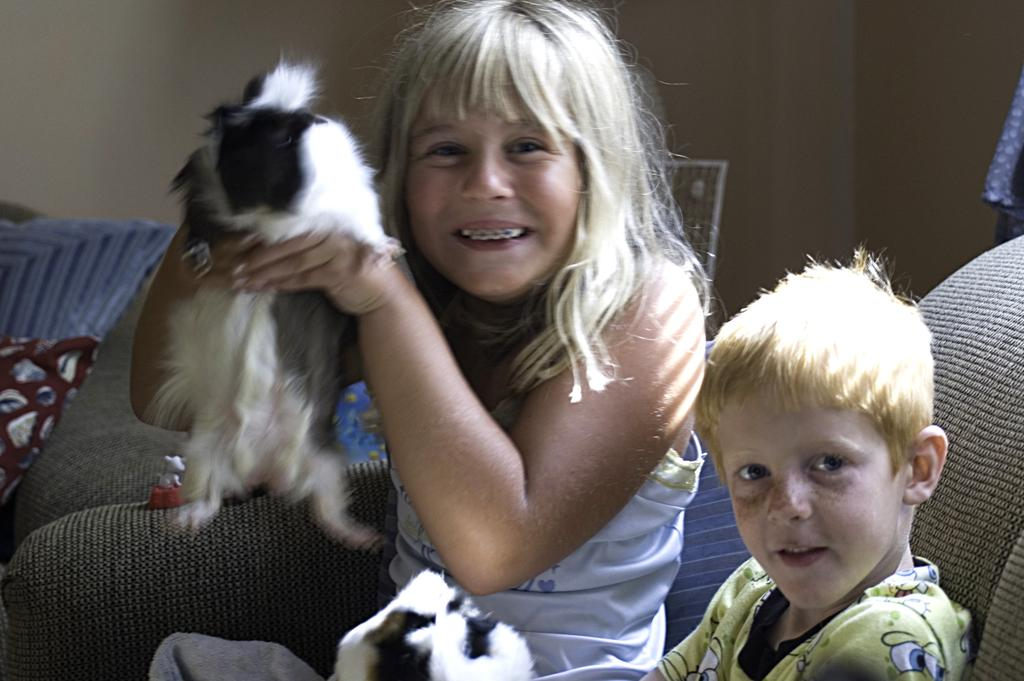Who is present in the image? There is a girl and a boy in the image. What is the girl holding in the image? The girl is holding a dog. What is the girl's facial expression in the image? The girl is smiling. What is the boy doing in the image? The boy is sitting on a chair. What type of engine can be seen in the image? There is no engine present in the image. What word is the girl saying to the dog in the image? The image does not show the girl saying any words to the dog, so it cannot be determined from the image. 